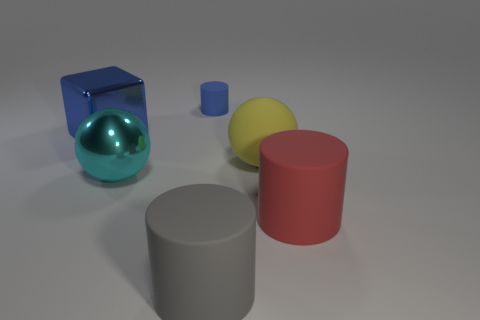Add 1 red matte cylinders. How many objects exist? 7 Subtract all spheres. How many objects are left? 4 Subtract 0 yellow cylinders. How many objects are left? 6 Subtract all cyan objects. Subtract all big cylinders. How many objects are left? 3 Add 1 rubber cylinders. How many rubber cylinders are left? 4 Add 6 cylinders. How many cylinders exist? 9 